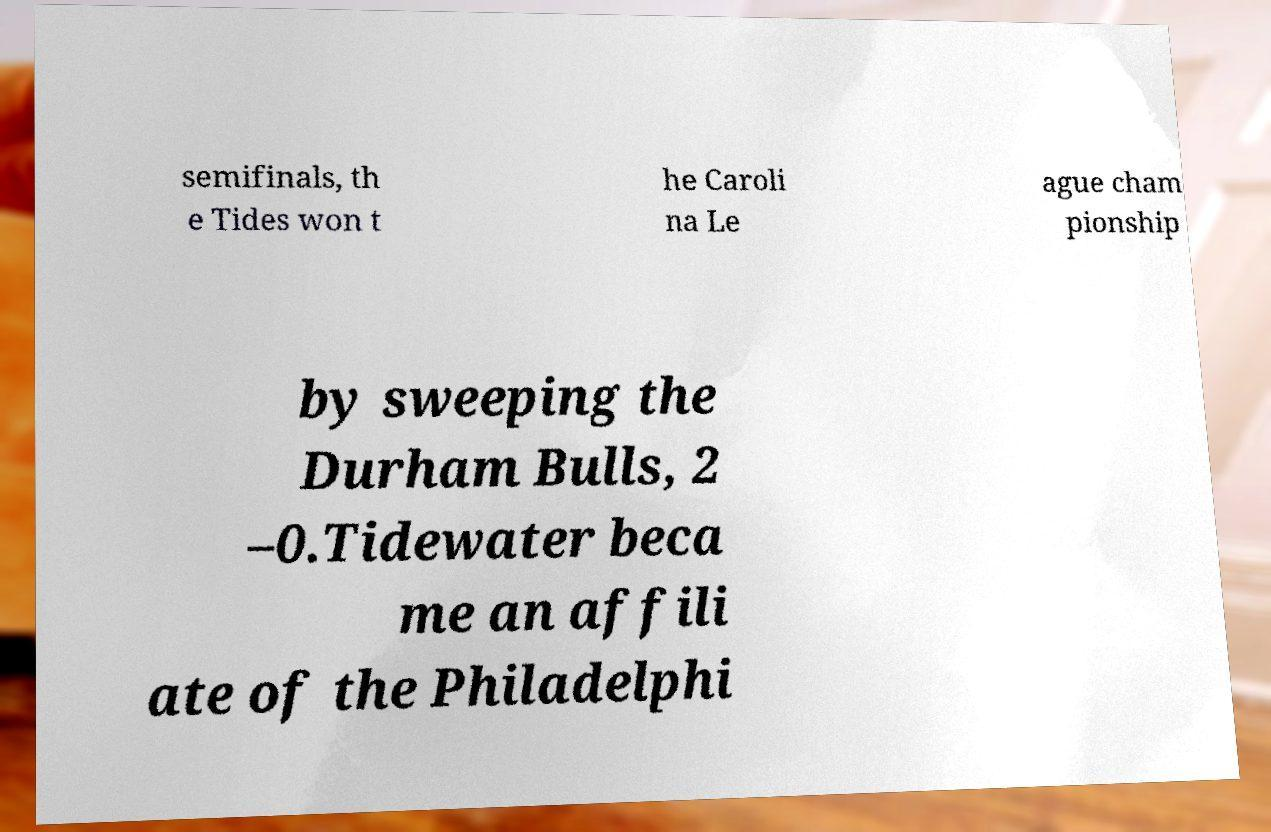I need the written content from this picture converted into text. Can you do that? semifinals, th e Tides won t he Caroli na Le ague cham pionship by sweeping the Durham Bulls, 2 –0.Tidewater beca me an affili ate of the Philadelphi 